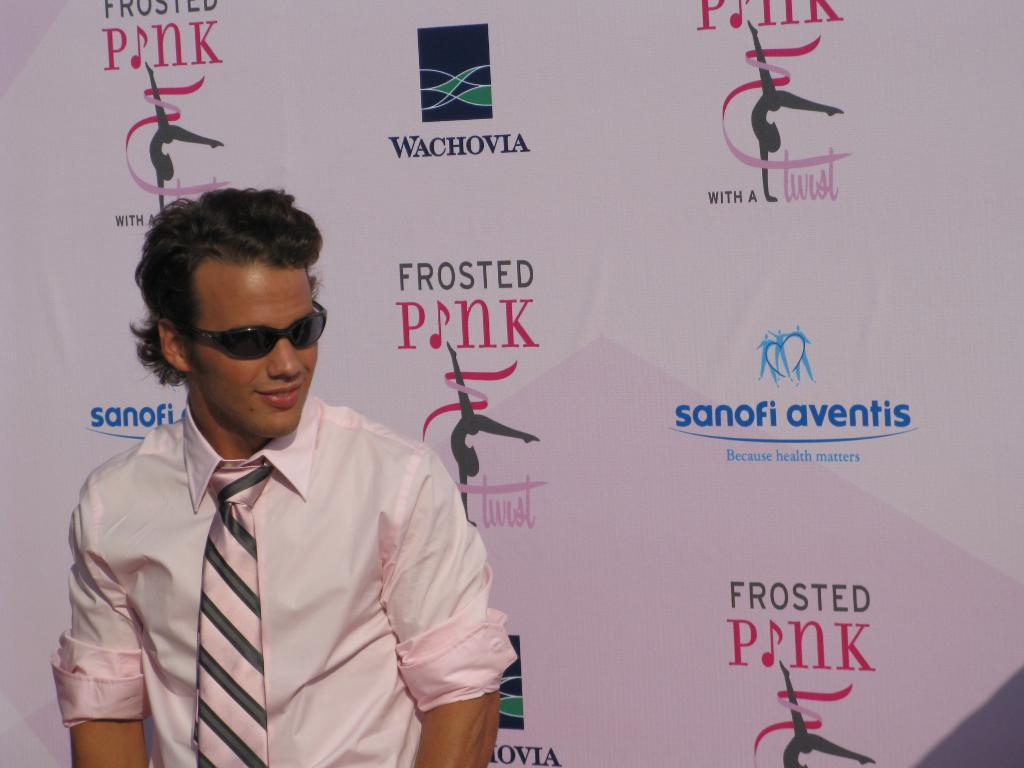Who or what is present in the image? There is a person in the image. What is the person wearing on their face? The person is wearing goggles. What type of clothing is the person wearing on their upper body? The person is wearing a shirt. Can you describe any accessories the person is wearing? A tie is visible on the left side of the person. What can be seen on the white surface in the image? There is some text on a white surface in the image. How does the person increase the size of the bead in the image? There is no bead present in the image, so it is not possible to answer that question. 